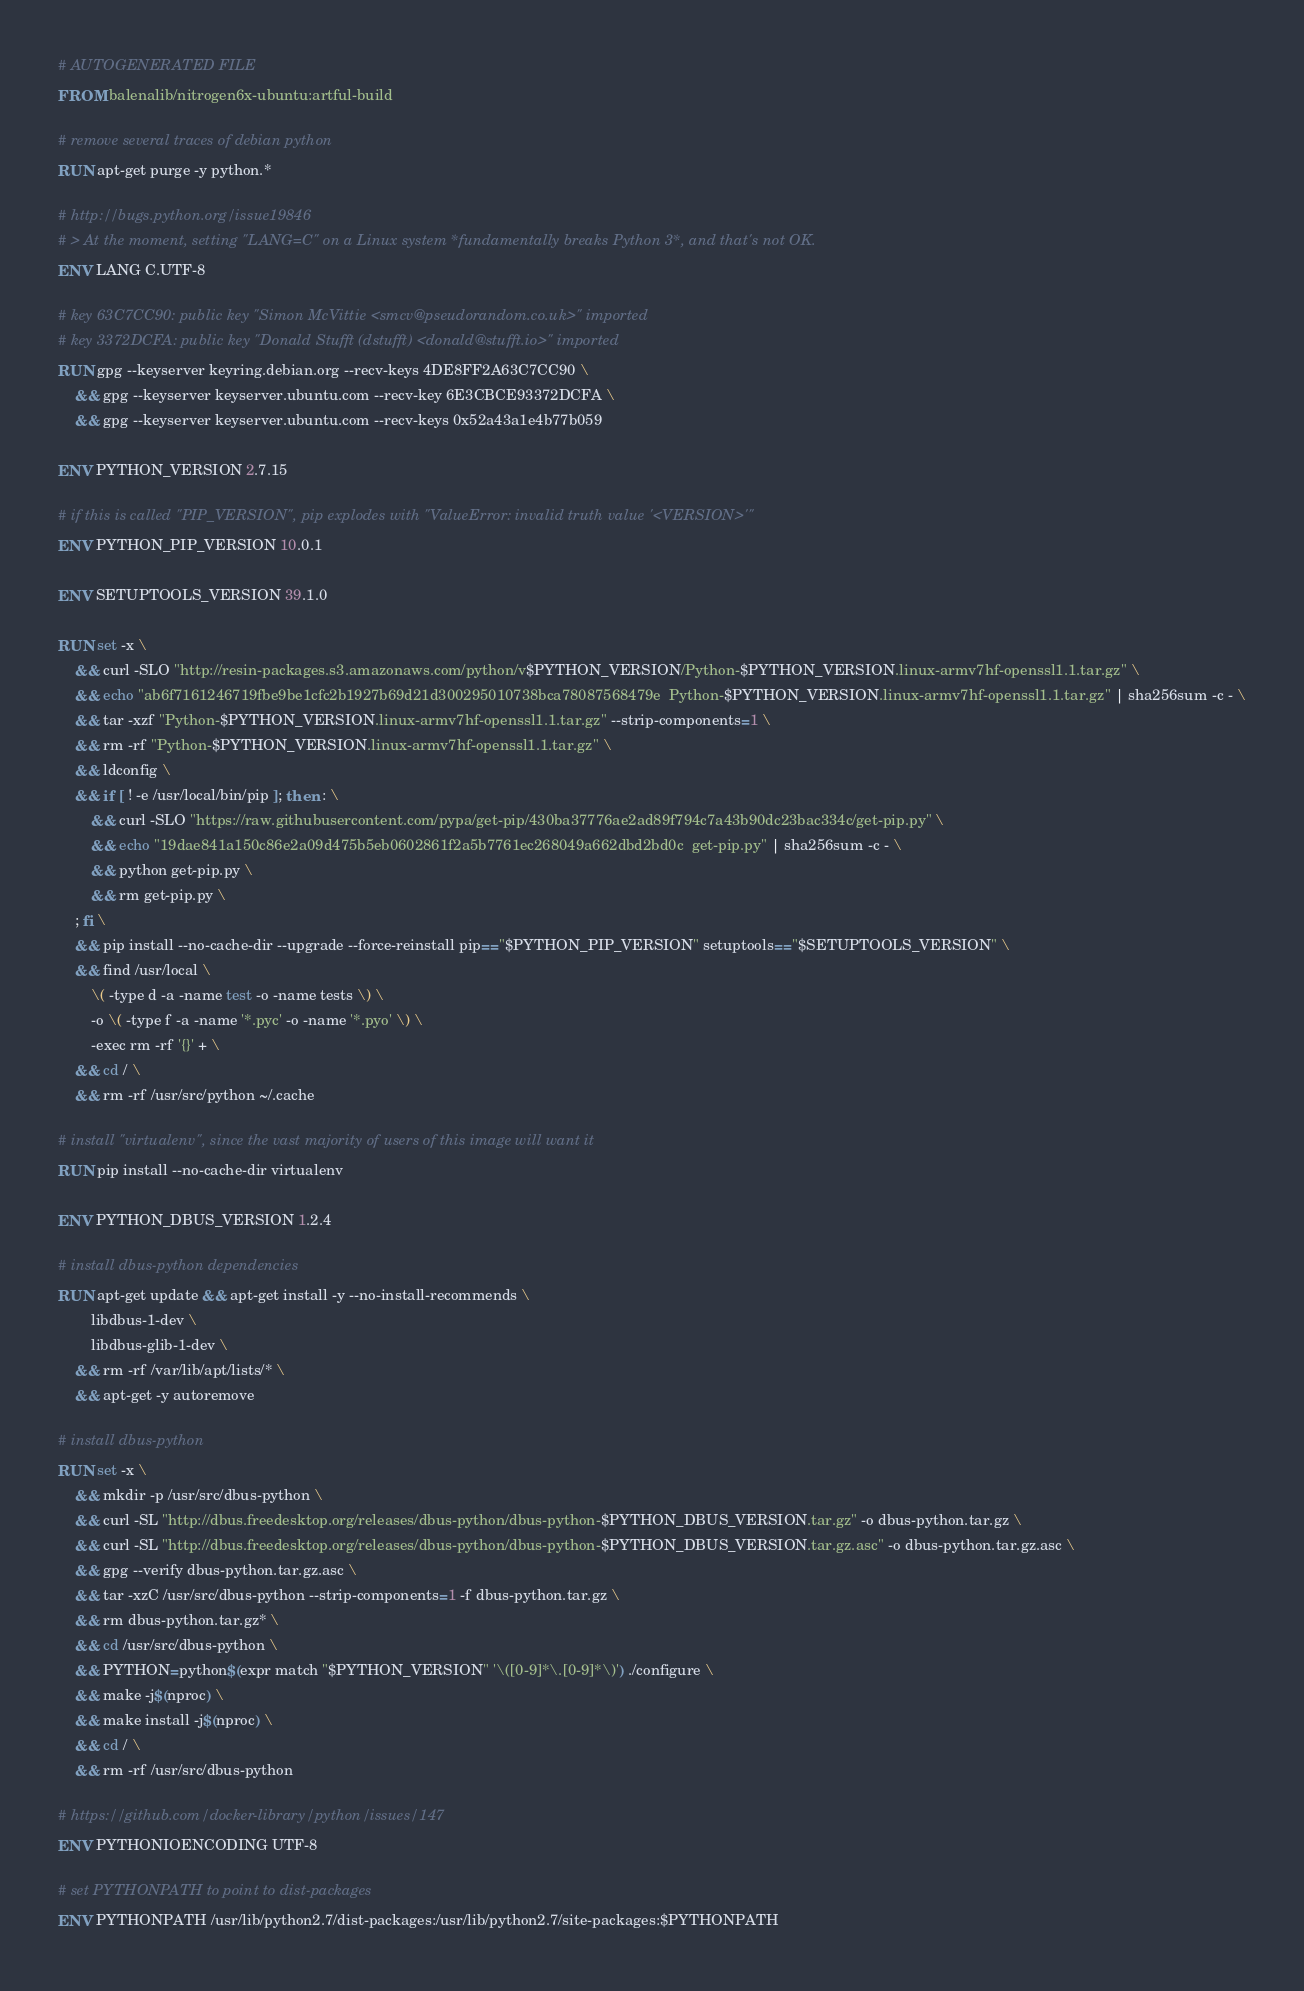<code> <loc_0><loc_0><loc_500><loc_500><_Dockerfile_># AUTOGENERATED FILE
FROM balenalib/nitrogen6x-ubuntu:artful-build

# remove several traces of debian python
RUN apt-get purge -y python.*

# http://bugs.python.org/issue19846
# > At the moment, setting "LANG=C" on a Linux system *fundamentally breaks Python 3*, and that's not OK.
ENV LANG C.UTF-8

# key 63C7CC90: public key "Simon McVittie <smcv@pseudorandom.co.uk>" imported
# key 3372DCFA: public key "Donald Stufft (dstufft) <donald@stufft.io>" imported
RUN gpg --keyserver keyring.debian.org --recv-keys 4DE8FF2A63C7CC90 \
	&& gpg --keyserver keyserver.ubuntu.com --recv-key 6E3CBCE93372DCFA \
	&& gpg --keyserver keyserver.ubuntu.com --recv-keys 0x52a43a1e4b77b059

ENV PYTHON_VERSION 2.7.15

# if this is called "PIP_VERSION", pip explodes with "ValueError: invalid truth value '<VERSION>'"
ENV PYTHON_PIP_VERSION 10.0.1

ENV SETUPTOOLS_VERSION 39.1.0

RUN set -x \
	&& curl -SLO "http://resin-packages.s3.amazonaws.com/python/v$PYTHON_VERSION/Python-$PYTHON_VERSION.linux-armv7hf-openssl1.1.tar.gz" \
	&& echo "ab6f7161246719fbe9be1cfc2b1927b69d21d300295010738bca78087568479e  Python-$PYTHON_VERSION.linux-armv7hf-openssl1.1.tar.gz" | sha256sum -c - \
	&& tar -xzf "Python-$PYTHON_VERSION.linux-armv7hf-openssl1.1.tar.gz" --strip-components=1 \
	&& rm -rf "Python-$PYTHON_VERSION.linux-armv7hf-openssl1.1.tar.gz" \
	&& ldconfig \
	&& if [ ! -e /usr/local/bin/pip ]; then : \
		&& curl -SLO "https://raw.githubusercontent.com/pypa/get-pip/430ba37776ae2ad89f794c7a43b90dc23bac334c/get-pip.py" \
		&& echo "19dae841a150c86e2a09d475b5eb0602861f2a5b7761ec268049a662dbd2bd0c  get-pip.py" | sha256sum -c - \
		&& python get-pip.py \
		&& rm get-pip.py \
	; fi \
	&& pip install --no-cache-dir --upgrade --force-reinstall pip=="$PYTHON_PIP_VERSION" setuptools=="$SETUPTOOLS_VERSION" \
	&& find /usr/local \
		\( -type d -a -name test -o -name tests \) \
		-o \( -type f -a -name '*.pyc' -o -name '*.pyo' \) \
		-exec rm -rf '{}' + \
	&& cd / \
	&& rm -rf /usr/src/python ~/.cache

# install "virtualenv", since the vast majority of users of this image will want it
RUN pip install --no-cache-dir virtualenv

ENV PYTHON_DBUS_VERSION 1.2.4

# install dbus-python dependencies 
RUN apt-get update && apt-get install -y --no-install-recommends \
		libdbus-1-dev \
		libdbus-glib-1-dev \
	&& rm -rf /var/lib/apt/lists/* \
	&& apt-get -y autoremove

# install dbus-python
RUN set -x \
	&& mkdir -p /usr/src/dbus-python \
	&& curl -SL "http://dbus.freedesktop.org/releases/dbus-python/dbus-python-$PYTHON_DBUS_VERSION.tar.gz" -o dbus-python.tar.gz \
	&& curl -SL "http://dbus.freedesktop.org/releases/dbus-python/dbus-python-$PYTHON_DBUS_VERSION.tar.gz.asc" -o dbus-python.tar.gz.asc \
	&& gpg --verify dbus-python.tar.gz.asc \
	&& tar -xzC /usr/src/dbus-python --strip-components=1 -f dbus-python.tar.gz \
	&& rm dbus-python.tar.gz* \
	&& cd /usr/src/dbus-python \
	&& PYTHON=python$(expr match "$PYTHON_VERSION" '\([0-9]*\.[0-9]*\)') ./configure \
	&& make -j$(nproc) \
	&& make install -j$(nproc) \
	&& cd / \
	&& rm -rf /usr/src/dbus-python

# https://github.com/docker-library/python/issues/147
ENV PYTHONIOENCODING UTF-8

# set PYTHONPATH to point to dist-packages
ENV PYTHONPATH /usr/lib/python2.7/dist-packages:/usr/lib/python2.7/site-packages:$PYTHONPATH
</code> 